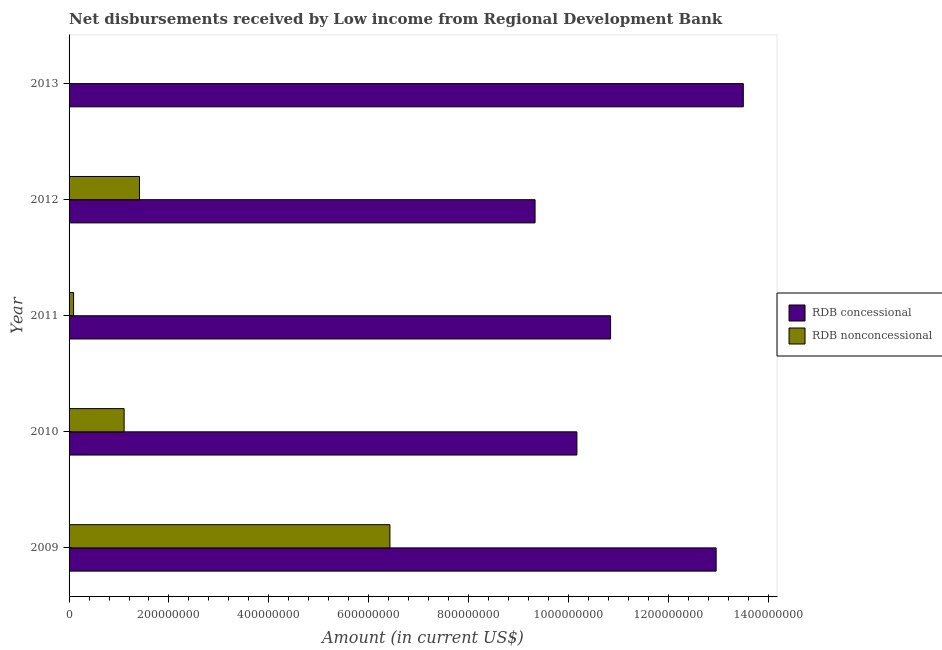How many different coloured bars are there?
Provide a succinct answer. 2. Are the number of bars per tick equal to the number of legend labels?
Provide a succinct answer. No. Are the number of bars on each tick of the Y-axis equal?
Keep it short and to the point. No. How many bars are there on the 2nd tick from the top?
Provide a succinct answer. 2. How many bars are there on the 5th tick from the bottom?
Your response must be concise. 1. What is the net concessional disbursements from rdb in 2009?
Keep it short and to the point. 1.30e+09. Across all years, what is the maximum net concessional disbursements from rdb?
Give a very brief answer. 1.35e+09. Across all years, what is the minimum net concessional disbursements from rdb?
Offer a terse response. 9.33e+08. What is the total net non concessional disbursements from rdb in the graph?
Provide a succinct answer. 9.03e+08. What is the difference between the net non concessional disbursements from rdb in 2009 and that in 2010?
Offer a terse response. 5.32e+08. What is the difference between the net concessional disbursements from rdb in 2013 and the net non concessional disbursements from rdb in 2010?
Provide a succinct answer. 1.24e+09. What is the average net non concessional disbursements from rdb per year?
Make the answer very short. 1.81e+08. In the year 2011, what is the difference between the net concessional disbursements from rdb and net non concessional disbursements from rdb?
Give a very brief answer. 1.08e+09. What is the ratio of the net concessional disbursements from rdb in 2009 to that in 2013?
Make the answer very short. 0.96. Is the net concessional disbursements from rdb in 2010 less than that in 2011?
Ensure brevity in your answer.  Yes. Is the difference between the net concessional disbursements from rdb in 2009 and 2011 greater than the difference between the net non concessional disbursements from rdb in 2009 and 2011?
Your answer should be very brief. No. What is the difference between the highest and the second highest net non concessional disbursements from rdb?
Ensure brevity in your answer.  5.01e+08. What is the difference between the highest and the lowest net concessional disbursements from rdb?
Provide a succinct answer. 4.17e+08. In how many years, is the net concessional disbursements from rdb greater than the average net concessional disbursements from rdb taken over all years?
Provide a short and direct response. 2. Is the sum of the net concessional disbursements from rdb in 2010 and 2012 greater than the maximum net non concessional disbursements from rdb across all years?
Your answer should be compact. Yes. Are all the bars in the graph horizontal?
Provide a succinct answer. Yes. What is the difference between two consecutive major ticks on the X-axis?
Offer a very short reply. 2.00e+08. Are the values on the major ticks of X-axis written in scientific E-notation?
Give a very brief answer. No. Where does the legend appear in the graph?
Ensure brevity in your answer.  Center right. What is the title of the graph?
Offer a terse response. Net disbursements received by Low income from Regional Development Bank. Does "Death rate" appear as one of the legend labels in the graph?
Make the answer very short. No. What is the label or title of the X-axis?
Provide a short and direct response. Amount (in current US$). What is the label or title of the Y-axis?
Provide a short and direct response. Year. What is the Amount (in current US$) of RDB concessional in 2009?
Your response must be concise. 1.30e+09. What is the Amount (in current US$) of RDB nonconcessional in 2009?
Your answer should be very brief. 6.42e+08. What is the Amount (in current US$) in RDB concessional in 2010?
Your answer should be compact. 1.02e+09. What is the Amount (in current US$) of RDB nonconcessional in 2010?
Give a very brief answer. 1.10e+08. What is the Amount (in current US$) in RDB concessional in 2011?
Provide a short and direct response. 1.08e+09. What is the Amount (in current US$) in RDB nonconcessional in 2011?
Offer a very short reply. 9.02e+06. What is the Amount (in current US$) of RDB concessional in 2012?
Keep it short and to the point. 9.33e+08. What is the Amount (in current US$) of RDB nonconcessional in 2012?
Make the answer very short. 1.41e+08. What is the Amount (in current US$) of RDB concessional in 2013?
Give a very brief answer. 1.35e+09. What is the Amount (in current US$) of RDB nonconcessional in 2013?
Keep it short and to the point. 0. Across all years, what is the maximum Amount (in current US$) in RDB concessional?
Your answer should be compact. 1.35e+09. Across all years, what is the maximum Amount (in current US$) of RDB nonconcessional?
Provide a short and direct response. 6.42e+08. Across all years, what is the minimum Amount (in current US$) in RDB concessional?
Provide a short and direct response. 9.33e+08. Across all years, what is the minimum Amount (in current US$) of RDB nonconcessional?
Ensure brevity in your answer.  0. What is the total Amount (in current US$) in RDB concessional in the graph?
Provide a succinct answer. 5.68e+09. What is the total Amount (in current US$) of RDB nonconcessional in the graph?
Your answer should be compact. 9.03e+08. What is the difference between the Amount (in current US$) in RDB concessional in 2009 and that in 2010?
Your answer should be very brief. 2.79e+08. What is the difference between the Amount (in current US$) in RDB nonconcessional in 2009 and that in 2010?
Provide a succinct answer. 5.32e+08. What is the difference between the Amount (in current US$) of RDB concessional in 2009 and that in 2011?
Provide a short and direct response. 2.11e+08. What is the difference between the Amount (in current US$) in RDB nonconcessional in 2009 and that in 2011?
Give a very brief answer. 6.33e+08. What is the difference between the Amount (in current US$) in RDB concessional in 2009 and that in 2012?
Provide a short and direct response. 3.63e+08. What is the difference between the Amount (in current US$) in RDB nonconcessional in 2009 and that in 2012?
Provide a short and direct response. 5.01e+08. What is the difference between the Amount (in current US$) of RDB concessional in 2009 and that in 2013?
Keep it short and to the point. -5.44e+07. What is the difference between the Amount (in current US$) in RDB concessional in 2010 and that in 2011?
Give a very brief answer. -6.74e+07. What is the difference between the Amount (in current US$) in RDB nonconcessional in 2010 and that in 2011?
Provide a short and direct response. 1.01e+08. What is the difference between the Amount (in current US$) of RDB concessional in 2010 and that in 2012?
Provide a succinct answer. 8.38e+07. What is the difference between the Amount (in current US$) in RDB nonconcessional in 2010 and that in 2012?
Keep it short and to the point. -3.08e+07. What is the difference between the Amount (in current US$) in RDB concessional in 2010 and that in 2013?
Provide a short and direct response. -3.33e+08. What is the difference between the Amount (in current US$) in RDB concessional in 2011 and that in 2012?
Give a very brief answer. 1.51e+08. What is the difference between the Amount (in current US$) in RDB nonconcessional in 2011 and that in 2012?
Your response must be concise. -1.32e+08. What is the difference between the Amount (in current US$) of RDB concessional in 2011 and that in 2013?
Offer a very short reply. -2.66e+08. What is the difference between the Amount (in current US$) of RDB concessional in 2012 and that in 2013?
Offer a terse response. -4.17e+08. What is the difference between the Amount (in current US$) of RDB concessional in 2009 and the Amount (in current US$) of RDB nonconcessional in 2010?
Ensure brevity in your answer.  1.19e+09. What is the difference between the Amount (in current US$) of RDB concessional in 2009 and the Amount (in current US$) of RDB nonconcessional in 2011?
Give a very brief answer. 1.29e+09. What is the difference between the Amount (in current US$) of RDB concessional in 2009 and the Amount (in current US$) of RDB nonconcessional in 2012?
Offer a terse response. 1.15e+09. What is the difference between the Amount (in current US$) in RDB concessional in 2010 and the Amount (in current US$) in RDB nonconcessional in 2011?
Your response must be concise. 1.01e+09. What is the difference between the Amount (in current US$) in RDB concessional in 2010 and the Amount (in current US$) in RDB nonconcessional in 2012?
Ensure brevity in your answer.  8.76e+08. What is the difference between the Amount (in current US$) of RDB concessional in 2011 and the Amount (in current US$) of RDB nonconcessional in 2012?
Offer a very short reply. 9.43e+08. What is the average Amount (in current US$) of RDB concessional per year?
Offer a terse response. 1.14e+09. What is the average Amount (in current US$) of RDB nonconcessional per year?
Your response must be concise. 1.81e+08. In the year 2009, what is the difference between the Amount (in current US$) of RDB concessional and Amount (in current US$) of RDB nonconcessional?
Offer a very short reply. 6.53e+08. In the year 2010, what is the difference between the Amount (in current US$) of RDB concessional and Amount (in current US$) of RDB nonconcessional?
Your answer should be compact. 9.07e+08. In the year 2011, what is the difference between the Amount (in current US$) in RDB concessional and Amount (in current US$) in RDB nonconcessional?
Keep it short and to the point. 1.08e+09. In the year 2012, what is the difference between the Amount (in current US$) of RDB concessional and Amount (in current US$) of RDB nonconcessional?
Keep it short and to the point. 7.92e+08. What is the ratio of the Amount (in current US$) of RDB concessional in 2009 to that in 2010?
Provide a succinct answer. 1.27. What is the ratio of the Amount (in current US$) in RDB nonconcessional in 2009 to that in 2010?
Make the answer very short. 5.83. What is the ratio of the Amount (in current US$) in RDB concessional in 2009 to that in 2011?
Your answer should be very brief. 1.2. What is the ratio of the Amount (in current US$) in RDB nonconcessional in 2009 to that in 2011?
Make the answer very short. 71.26. What is the ratio of the Amount (in current US$) in RDB concessional in 2009 to that in 2012?
Your answer should be very brief. 1.39. What is the ratio of the Amount (in current US$) of RDB nonconcessional in 2009 to that in 2012?
Make the answer very short. 4.55. What is the ratio of the Amount (in current US$) in RDB concessional in 2009 to that in 2013?
Offer a very short reply. 0.96. What is the ratio of the Amount (in current US$) of RDB concessional in 2010 to that in 2011?
Keep it short and to the point. 0.94. What is the ratio of the Amount (in current US$) in RDB nonconcessional in 2010 to that in 2011?
Offer a terse response. 12.23. What is the ratio of the Amount (in current US$) of RDB concessional in 2010 to that in 2012?
Keep it short and to the point. 1.09. What is the ratio of the Amount (in current US$) of RDB nonconcessional in 2010 to that in 2012?
Ensure brevity in your answer.  0.78. What is the ratio of the Amount (in current US$) of RDB concessional in 2010 to that in 2013?
Provide a short and direct response. 0.75. What is the ratio of the Amount (in current US$) of RDB concessional in 2011 to that in 2012?
Your response must be concise. 1.16. What is the ratio of the Amount (in current US$) of RDB nonconcessional in 2011 to that in 2012?
Your answer should be compact. 0.06. What is the ratio of the Amount (in current US$) in RDB concessional in 2011 to that in 2013?
Provide a succinct answer. 0.8. What is the ratio of the Amount (in current US$) of RDB concessional in 2012 to that in 2013?
Provide a succinct answer. 0.69. What is the difference between the highest and the second highest Amount (in current US$) of RDB concessional?
Your answer should be compact. 5.44e+07. What is the difference between the highest and the second highest Amount (in current US$) in RDB nonconcessional?
Provide a succinct answer. 5.01e+08. What is the difference between the highest and the lowest Amount (in current US$) in RDB concessional?
Give a very brief answer. 4.17e+08. What is the difference between the highest and the lowest Amount (in current US$) of RDB nonconcessional?
Offer a very short reply. 6.42e+08. 